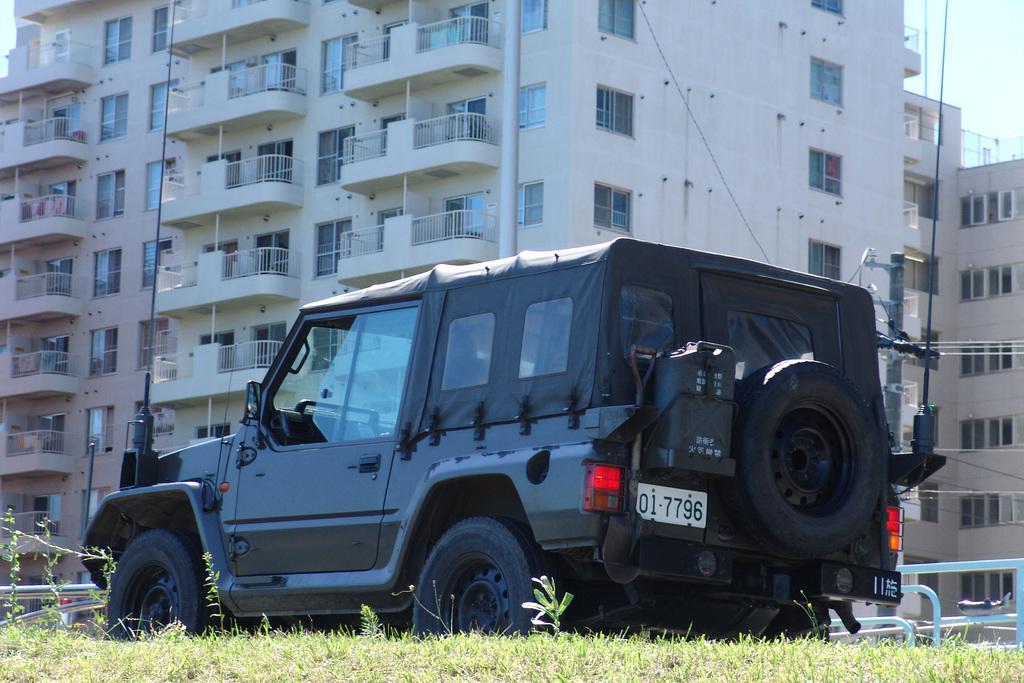Please provide a concise description of this image. In this image I can see few buildings, windows, green grass, railing, current pole, wires and black vehicle. 